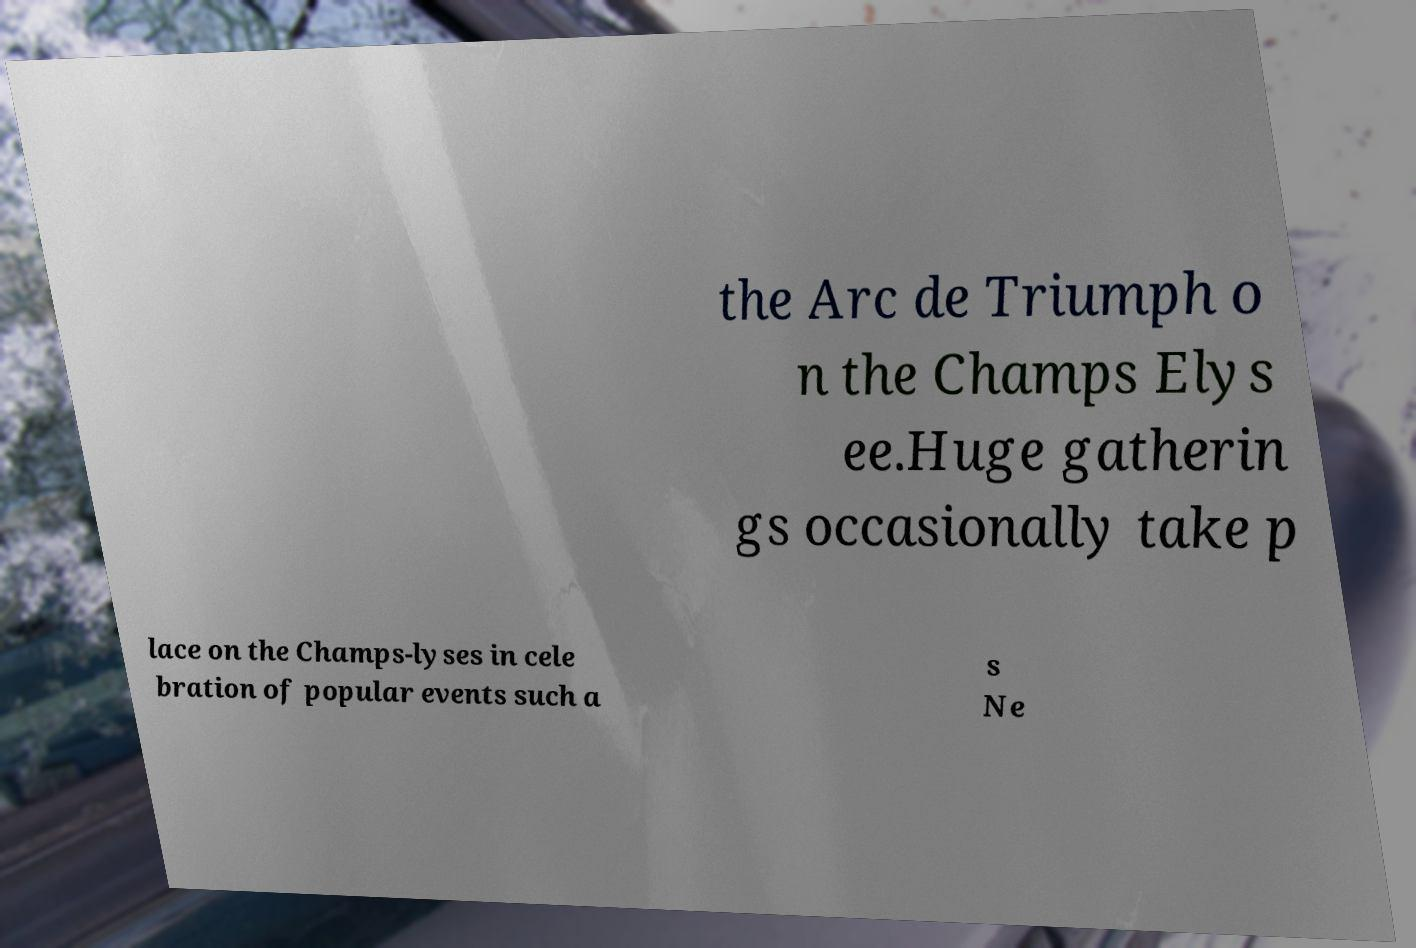Can you accurately transcribe the text from the provided image for me? the Arc de Triumph o n the Champs Elys ee.Huge gatherin gs occasionally take p lace on the Champs-lyses in cele bration of popular events such a s Ne 